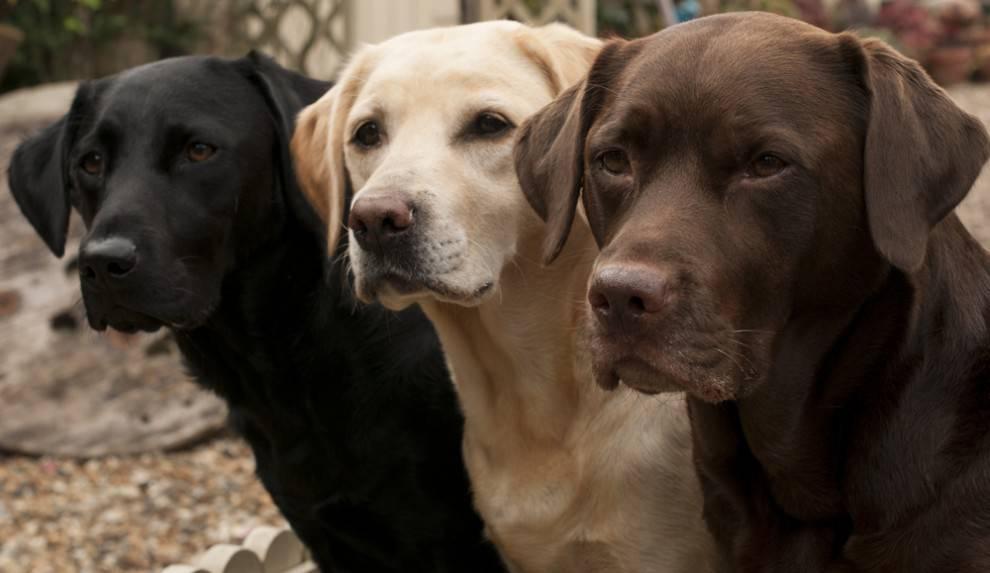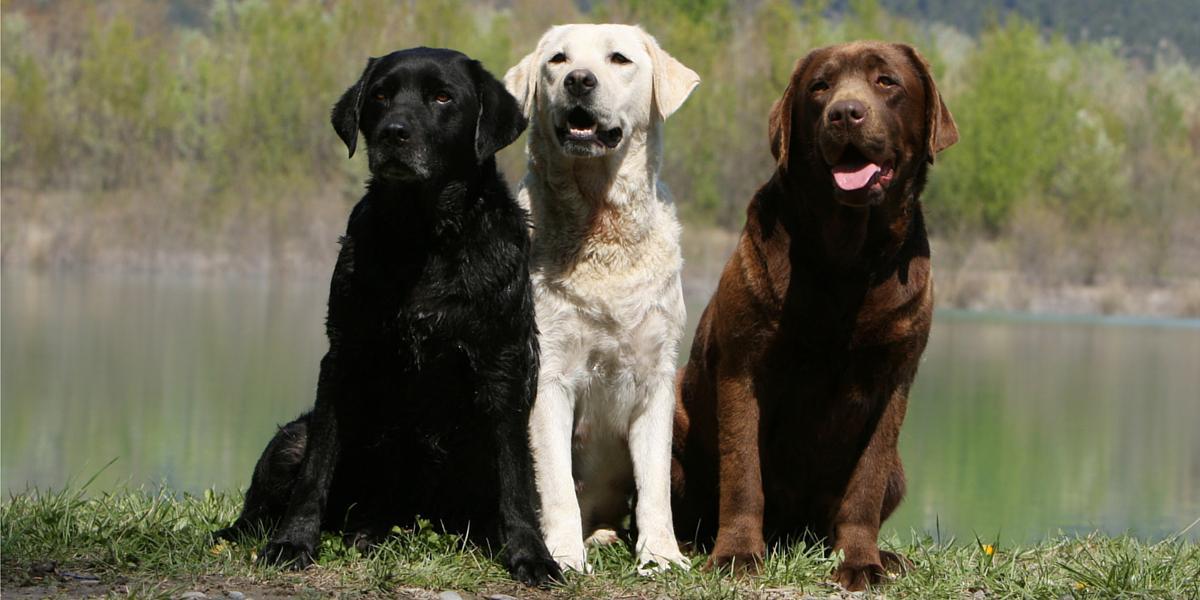The first image is the image on the left, the second image is the image on the right. Evaluate the accuracy of this statement regarding the images: "labs are sitting near a river". Is it true? Answer yes or no. Yes. The first image is the image on the left, the second image is the image on the right. Assess this claim about the two images: "The image on the right has three dogs that are all sitting.". Correct or not? Answer yes or no. Yes. 